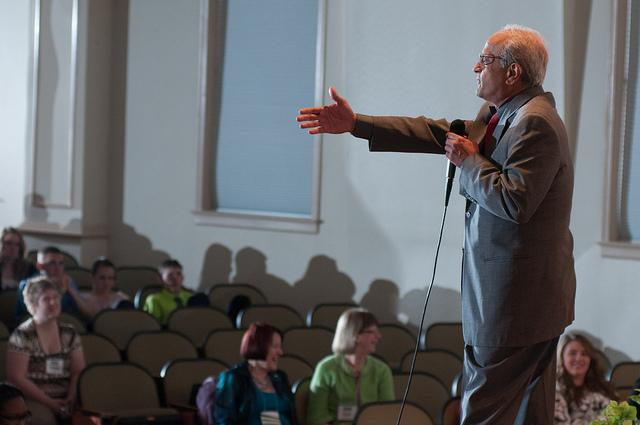How many people are wearing green shirts?
Be succinct. 2. What is the man holding?
Quick response, please. Microphone. Are there any seats available?
Quick response, please. Yes. 